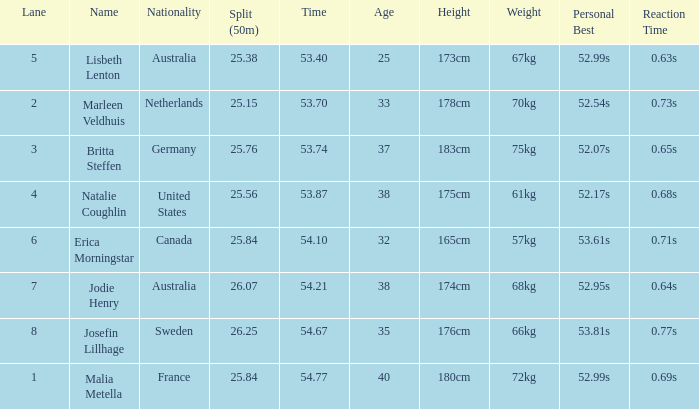What is the slowest 50m split time for a total of 53.74 in a lane of less than 3? None. 